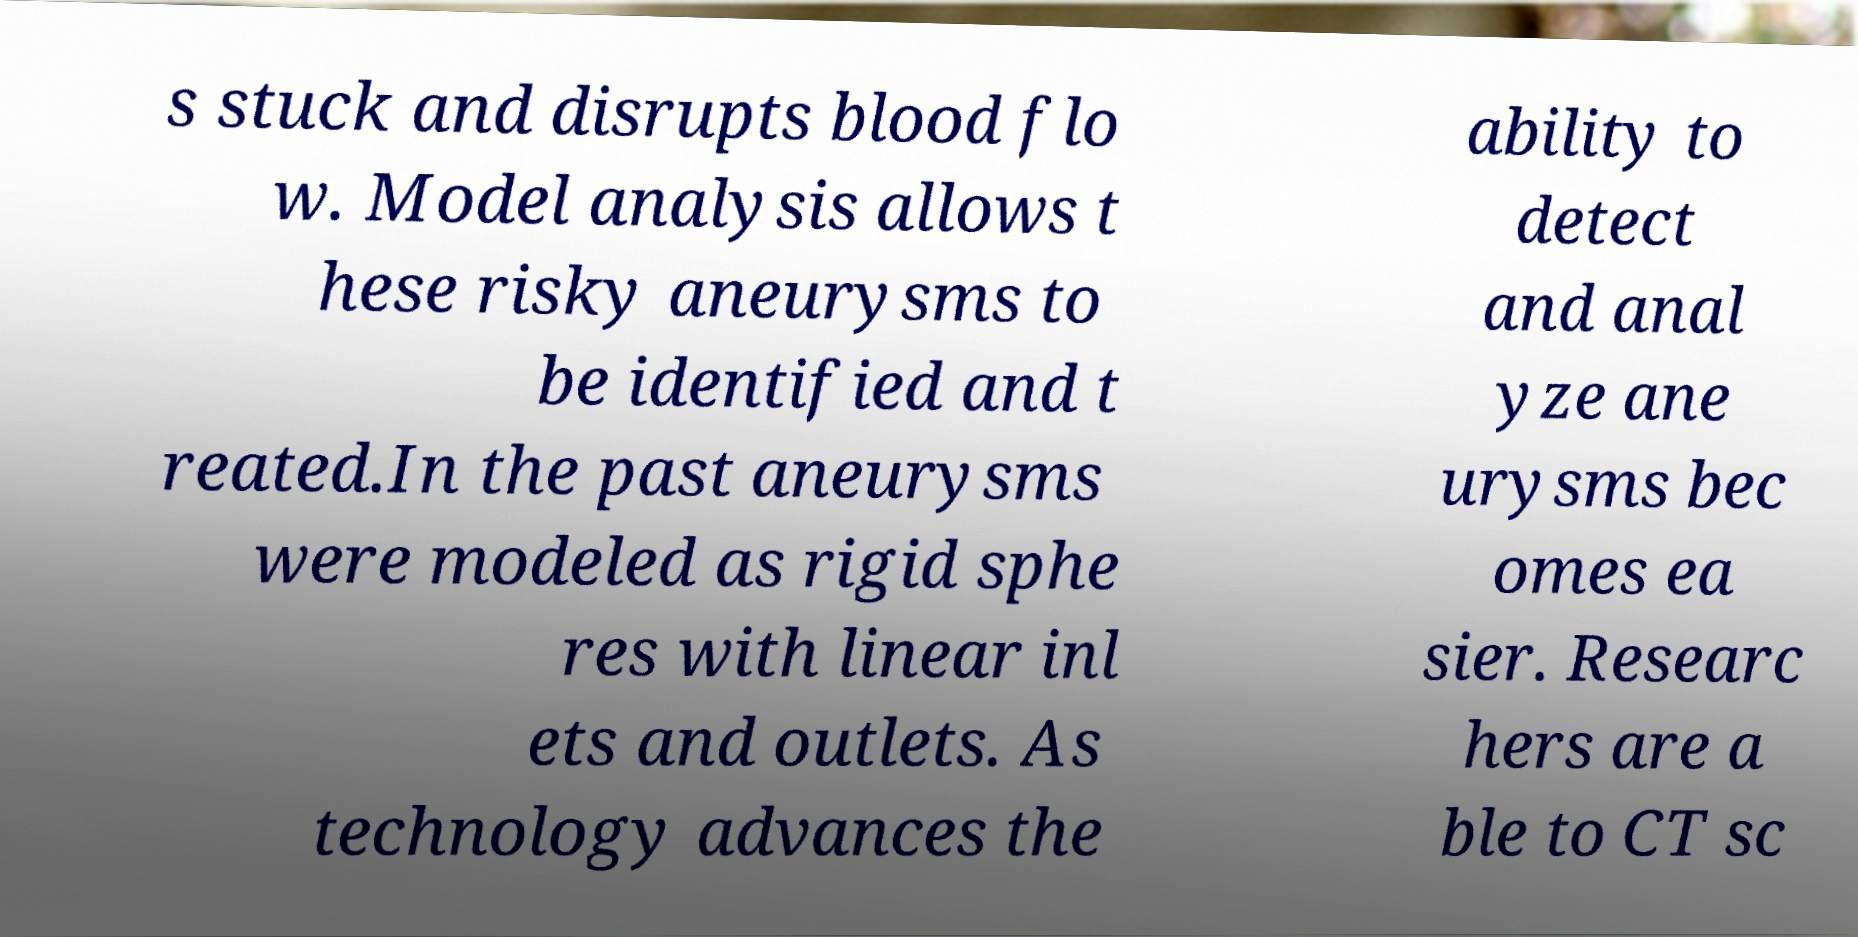There's text embedded in this image that I need extracted. Can you transcribe it verbatim? s stuck and disrupts blood flo w. Model analysis allows t hese risky aneurysms to be identified and t reated.In the past aneurysms were modeled as rigid sphe res with linear inl ets and outlets. As technology advances the ability to detect and anal yze ane urysms bec omes ea sier. Researc hers are a ble to CT sc 